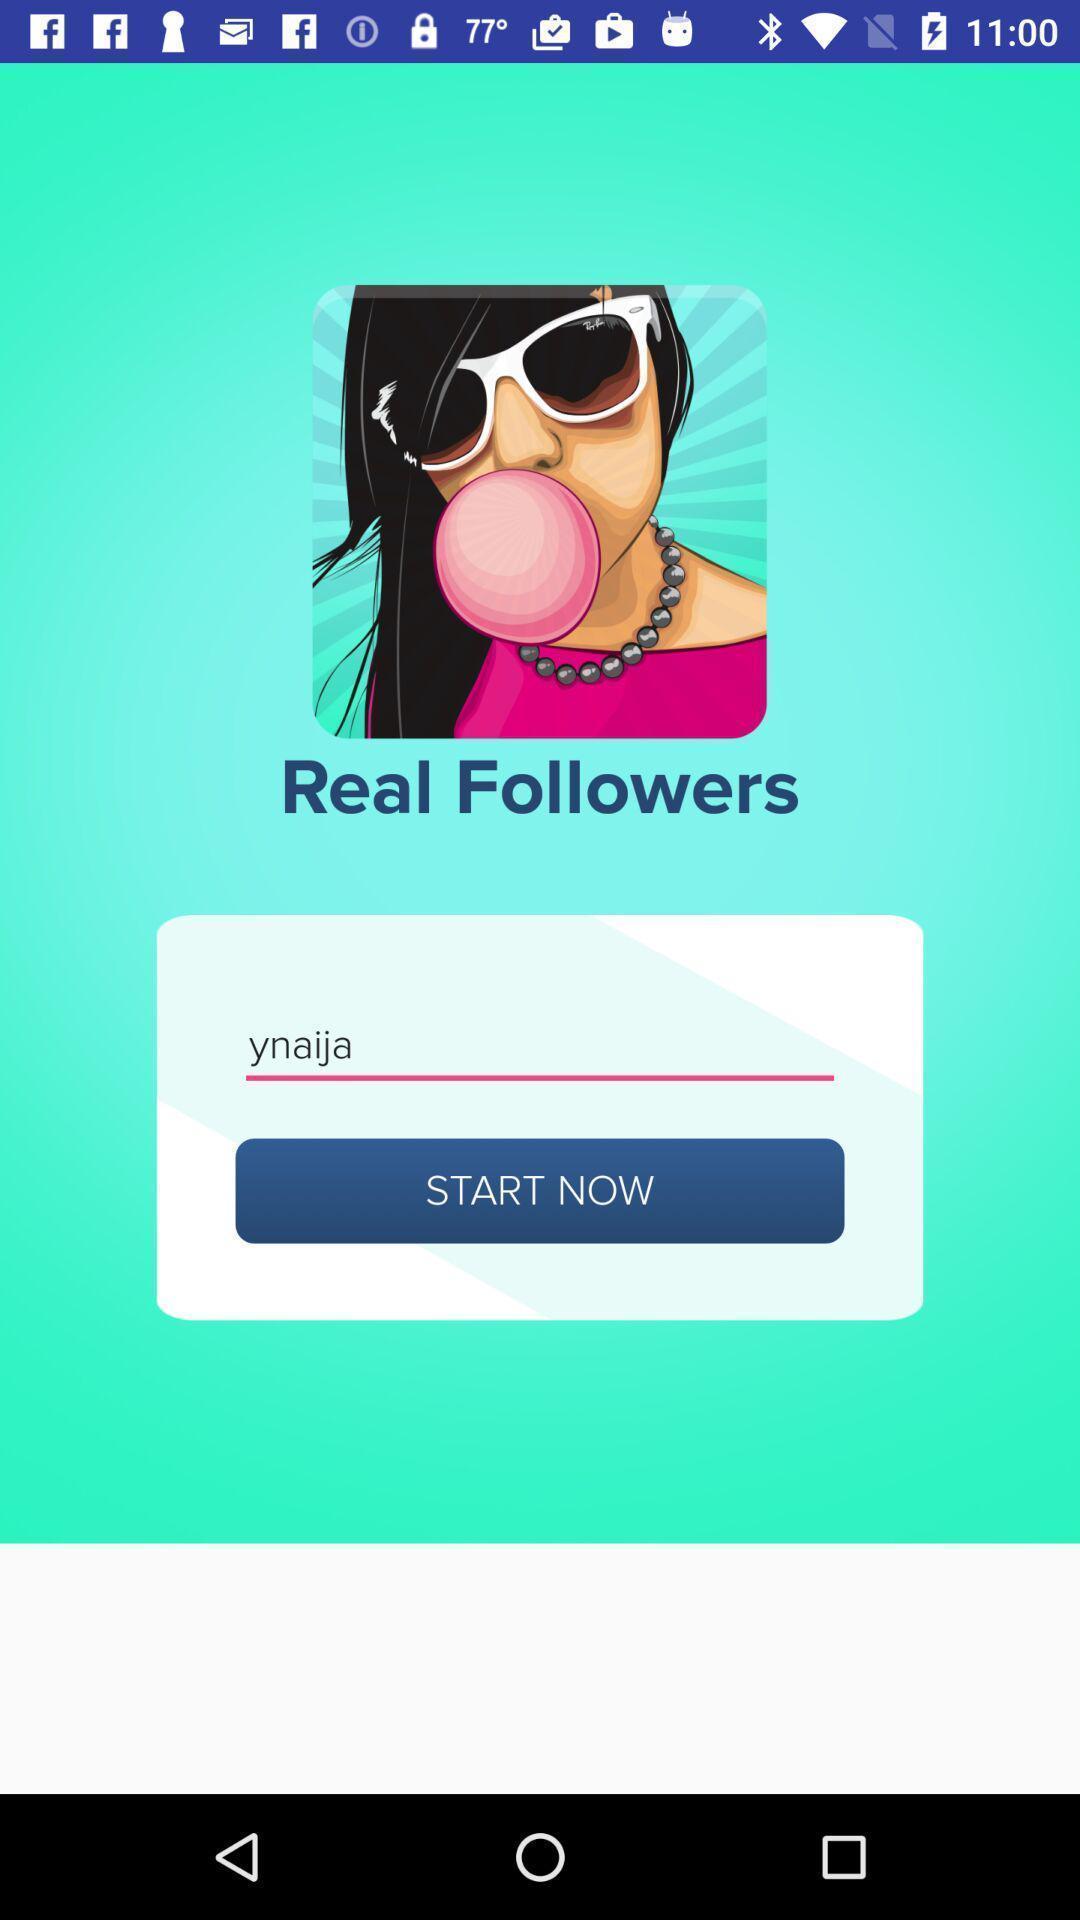Provide a description of this screenshot. Starting page. 